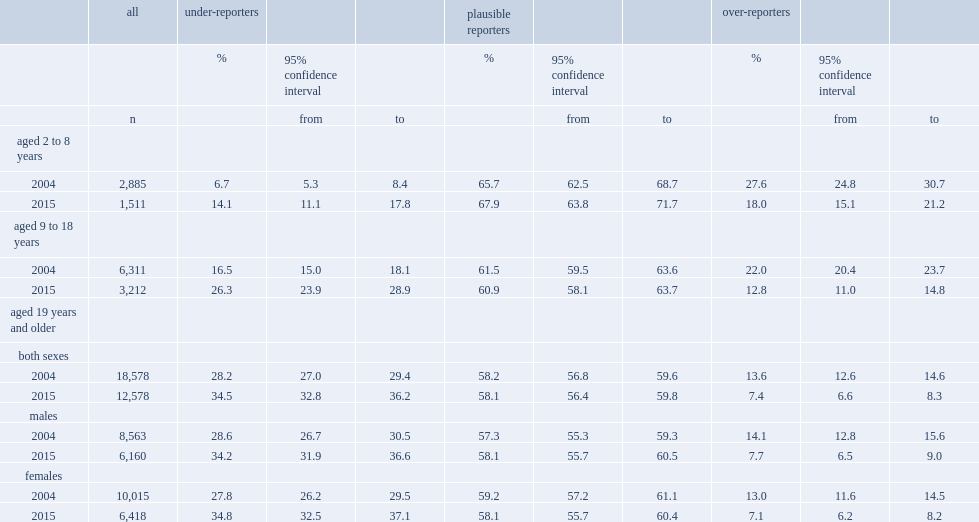Which year has a higher number of under-reporters regardless of age or sex? 2015.0. How many times has the percentage of under-reporters increased in the youngest age group? 2.104478. Which group of people has been dereased from 2004 to 2015 significantly mostly? Over-reporters. What is the most prevalent misreporting status? Plausible reporters. 